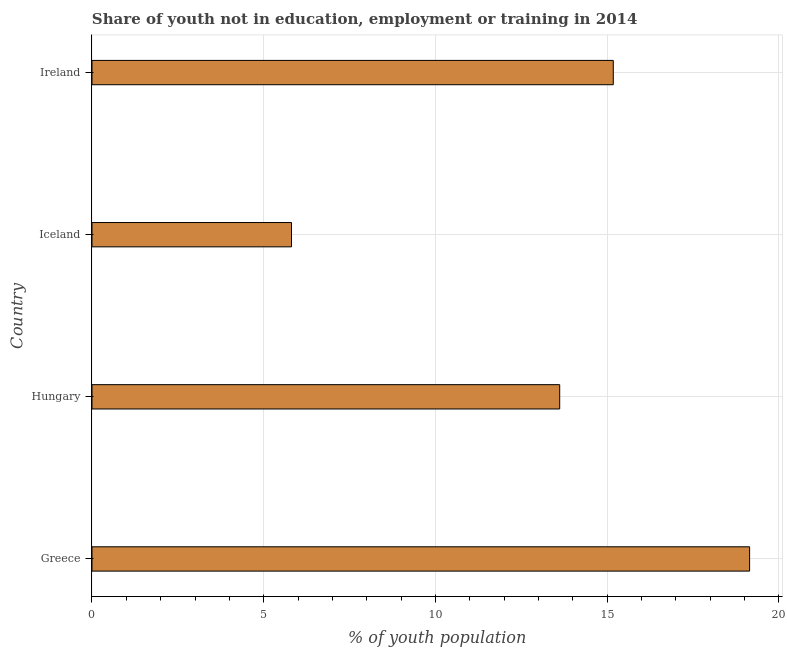Does the graph contain any zero values?
Your answer should be compact. No. Does the graph contain grids?
Your answer should be compact. Yes. What is the title of the graph?
Provide a succinct answer. Share of youth not in education, employment or training in 2014. What is the label or title of the X-axis?
Your response must be concise. % of youth population. What is the label or title of the Y-axis?
Your response must be concise. Country. What is the unemployed youth population in Iceland?
Provide a succinct answer. 5.81. Across all countries, what is the maximum unemployed youth population?
Your response must be concise. 19.15. Across all countries, what is the minimum unemployed youth population?
Your answer should be very brief. 5.81. What is the sum of the unemployed youth population?
Your answer should be very brief. 53.76. What is the difference between the unemployed youth population in Greece and Ireland?
Offer a terse response. 3.97. What is the average unemployed youth population per country?
Give a very brief answer. 13.44. What is the median unemployed youth population?
Offer a very short reply. 14.4. In how many countries, is the unemployed youth population greater than 7 %?
Your response must be concise. 3. What is the ratio of the unemployed youth population in Greece to that in Iceland?
Ensure brevity in your answer.  3.3. Is the unemployed youth population in Greece less than that in Ireland?
Offer a terse response. No. What is the difference between the highest and the second highest unemployed youth population?
Provide a short and direct response. 3.97. Is the sum of the unemployed youth population in Hungary and Iceland greater than the maximum unemployed youth population across all countries?
Provide a short and direct response. Yes. What is the difference between the highest and the lowest unemployed youth population?
Ensure brevity in your answer.  13.34. In how many countries, is the unemployed youth population greater than the average unemployed youth population taken over all countries?
Offer a very short reply. 3. How many bars are there?
Provide a short and direct response. 4. What is the difference between two consecutive major ticks on the X-axis?
Your answer should be compact. 5. Are the values on the major ticks of X-axis written in scientific E-notation?
Offer a very short reply. No. What is the % of youth population of Greece?
Provide a succinct answer. 19.15. What is the % of youth population in Hungary?
Give a very brief answer. 13.62. What is the % of youth population of Iceland?
Keep it short and to the point. 5.81. What is the % of youth population of Ireland?
Make the answer very short. 15.18. What is the difference between the % of youth population in Greece and Hungary?
Your response must be concise. 5.53. What is the difference between the % of youth population in Greece and Iceland?
Your answer should be compact. 13.34. What is the difference between the % of youth population in Greece and Ireland?
Offer a very short reply. 3.97. What is the difference between the % of youth population in Hungary and Iceland?
Keep it short and to the point. 7.81. What is the difference between the % of youth population in Hungary and Ireland?
Ensure brevity in your answer.  -1.56. What is the difference between the % of youth population in Iceland and Ireland?
Keep it short and to the point. -9.37. What is the ratio of the % of youth population in Greece to that in Hungary?
Your answer should be very brief. 1.41. What is the ratio of the % of youth population in Greece to that in Iceland?
Keep it short and to the point. 3.3. What is the ratio of the % of youth population in Greece to that in Ireland?
Your answer should be very brief. 1.26. What is the ratio of the % of youth population in Hungary to that in Iceland?
Give a very brief answer. 2.34. What is the ratio of the % of youth population in Hungary to that in Ireland?
Provide a short and direct response. 0.9. What is the ratio of the % of youth population in Iceland to that in Ireland?
Ensure brevity in your answer.  0.38. 